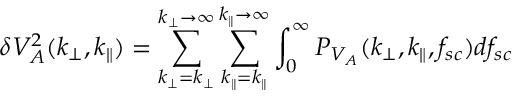Convert formula to latex. <formula><loc_0><loc_0><loc_500><loc_500>\delta V _ { A } ^ { 2 } ( k _ { \perp } , k _ { \| } ) = \sum _ { k _ { \perp } = k _ { \perp } } ^ { k _ { \perp } \rightarrow \infty } \sum _ { k _ { \| } = k _ { \| } } ^ { k _ { \| } \rightarrow \infty } \int _ { 0 } ^ { \infty } P _ { V _ { A } } ( k _ { \perp } , k _ { \| } , f _ { s c } ) d f _ { s c }</formula> 